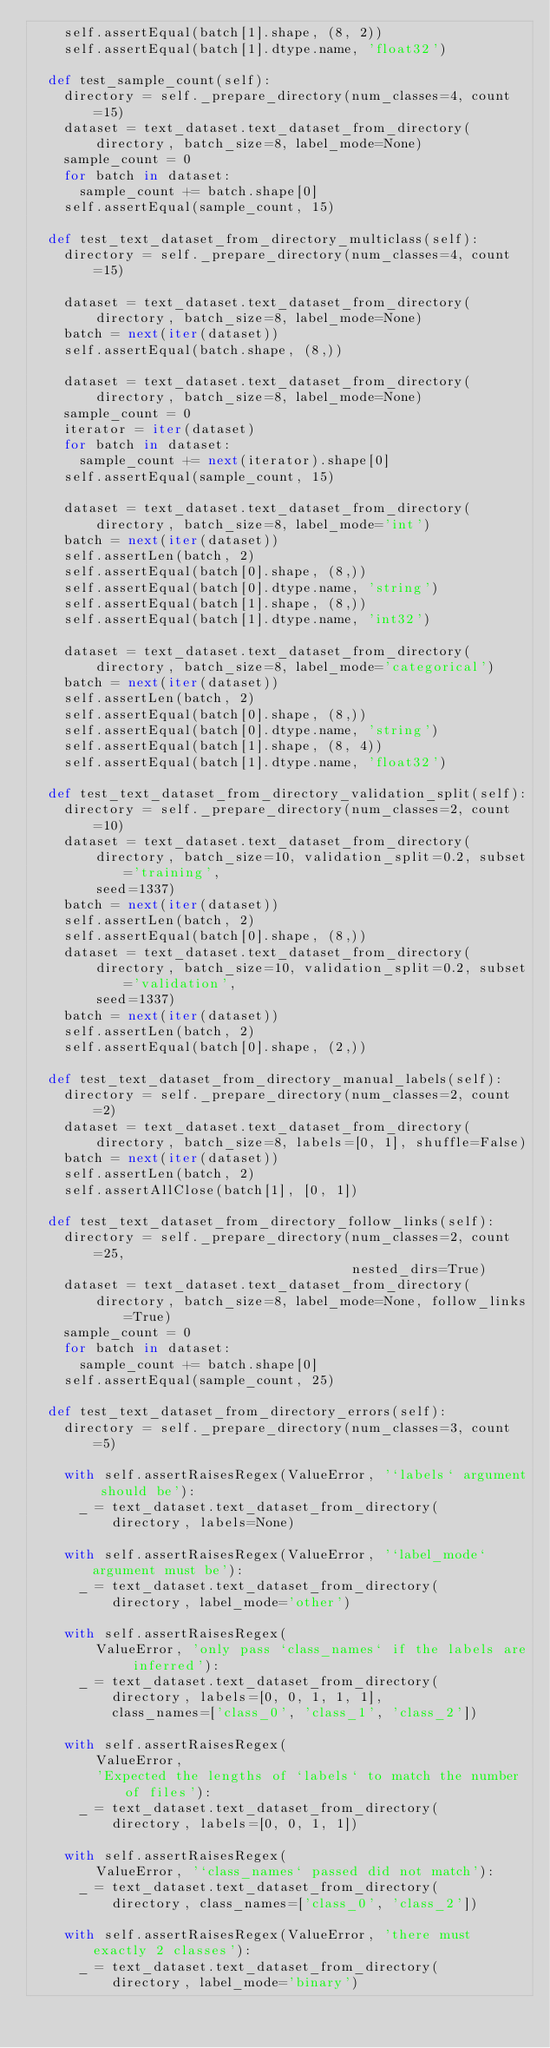<code> <loc_0><loc_0><loc_500><loc_500><_Python_>    self.assertEqual(batch[1].shape, (8, 2))
    self.assertEqual(batch[1].dtype.name, 'float32')

  def test_sample_count(self):
    directory = self._prepare_directory(num_classes=4, count=15)
    dataset = text_dataset.text_dataset_from_directory(
        directory, batch_size=8, label_mode=None)
    sample_count = 0
    for batch in dataset:
      sample_count += batch.shape[0]
    self.assertEqual(sample_count, 15)

  def test_text_dataset_from_directory_multiclass(self):
    directory = self._prepare_directory(num_classes=4, count=15)

    dataset = text_dataset.text_dataset_from_directory(
        directory, batch_size=8, label_mode=None)
    batch = next(iter(dataset))
    self.assertEqual(batch.shape, (8,))

    dataset = text_dataset.text_dataset_from_directory(
        directory, batch_size=8, label_mode=None)
    sample_count = 0
    iterator = iter(dataset)
    for batch in dataset:
      sample_count += next(iterator).shape[0]
    self.assertEqual(sample_count, 15)

    dataset = text_dataset.text_dataset_from_directory(
        directory, batch_size=8, label_mode='int')
    batch = next(iter(dataset))
    self.assertLen(batch, 2)
    self.assertEqual(batch[0].shape, (8,))
    self.assertEqual(batch[0].dtype.name, 'string')
    self.assertEqual(batch[1].shape, (8,))
    self.assertEqual(batch[1].dtype.name, 'int32')

    dataset = text_dataset.text_dataset_from_directory(
        directory, batch_size=8, label_mode='categorical')
    batch = next(iter(dataset))
    self.assertLen(batch, 2)
    self.assertEqual(batch[0].shape, (8,))
    self.assertEqual(batch[0].dtype.name, 'string')
    self.assertEqual(batch[1].shape, (8, 4))
    self.assertEqual(batch[1].dtype.name, 'float32')

  def test_text_dataset_from_directory_validation_split(self):
    directory = self._prepare_directory(num_classes=2, count=10)
    dataset = text_dataset.text_dataset_from_directory(
        directory, batch_size=10, validation_split=0.2, subset='training',
        seed=1337)
    batch = next(iter(dataset))
    self.assertLen(batch, 2)
    self.assertEqual(batch[0].shape, (8,))
    dataset = text_dataset.text_dataset_from_directory(
        directory, batch_size=10, validation_split=0.2, subset='validation',
        seed=1337)
    batch = next(iter(dataset))
    self.assertLen(batch, 2)
    self.assertEqual(batch[0].shape, (2,))

  def test_text_dataset_from_directory_manual_labels(self):
    directory = self._prepare_directory(num_classes=2, count=2)
    dataset = text_dataset.text_dataset_from_directory(
        directory, batch_size=8, labels=[0, 1], shuffle=False)
    batch = next(iter(dataset))
    self.assertLen(batch, 2)
    self.assertAllClose(batch[1], [0, 1])

  def test_text_dataset_from_directory_follow_links(self):
    directory = self._prepare_directory(num_classes=2, count=25,
                                        nested_dirs=True)
    dataset = text_dataset.text_dataset_from_directory(
        directory, batch_size=8, label_mode=None, follow_links=True)
    sample_count = 0
    for batch in dataset:
      sample_count += batch.shape[0]
    self.assertEqual(sample_count, 25)

  def test_text_dataset_from_directory_errors(self):
    directory = self._prepare_directory(num_classes=3, count=5)

    with self.assertRaisesRegex(ValueError, '`labels` argument should be'):
      _ = text_dataset.text_dataset_from_directory(
          directory, labels=None)

    with self.assertRaisesRegex(ValueError, '`label_mode` argument must be'):
      _ = text_dataset.text_dataset_from_directory(
          directory, label_mode='other')

    with self.assertRaisesRegex(
        ValueError, 'only pass `class_names` if the labels are inferred'):
      _ = text_dataset.text_dataset_from_directory(
          directory, labels=[0, 0, 1, 1, 1],
          class_names=['class_0', 'class_1', 'class_2'])

    with self.assertRaisesRegex(
        ValueError,
        'Expected the lengths of `labels` to match the number of files'):
      _ = text_dataset.text_dataset_from_directory(
          directory, labels=[0, 0, 1, 1])

    with self.assertRaisesRegex(
        ValueError, '`class_names` passed did not match'):
      _ = text_dataset.text_dataset_from_directory(
          directory, class_names=['class_0', 'class_2'])

    with self.assertRaisesRegex(ValueError, 'there must exactly 2 classes'):
      _ = text_dataset.text_dataset_from_directory(
          directory, label_mode='binary')
</code> 